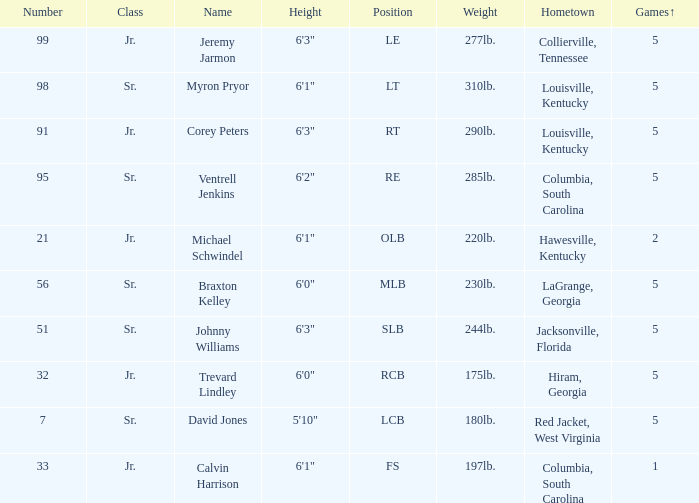What was Trevard Lindley's number? 32.0. 